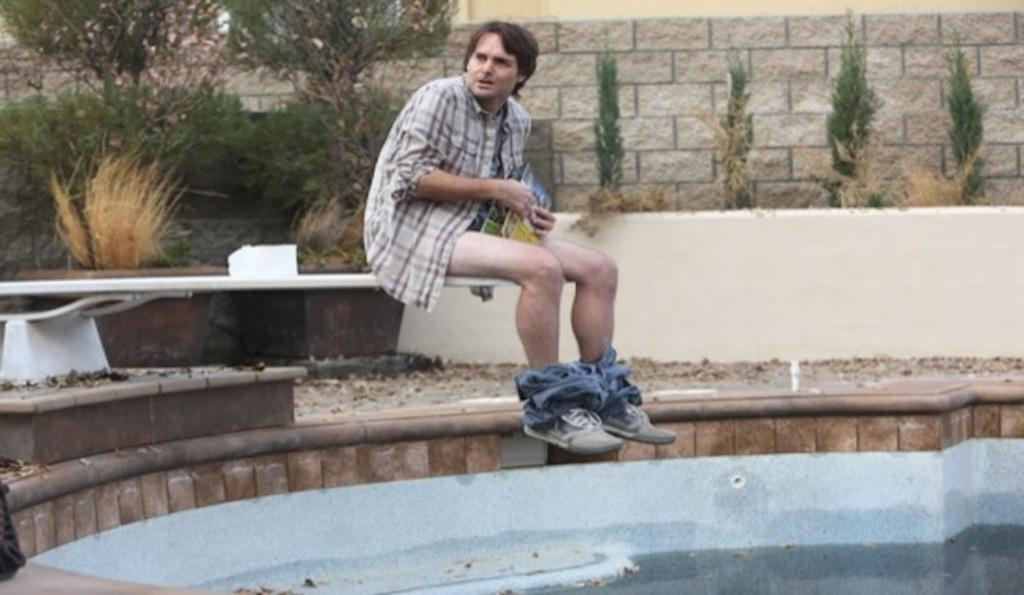What is in the pool in the image? There is water in a pool in the image. What is the man near the pool doing? The man is sitting near the pool. What is the man wearing? The man is wearing a shirt. What is the man holding? The man is holding a book. What can be seen at the back of the scene? There are plants and a brick wall at the back. What degree of silence can be heard in the image? The image does not convey any auditory information, so it is impossible to determine the degree of silence or any other sound. What color is the silver object in the image? There is no silver object present in the image. 